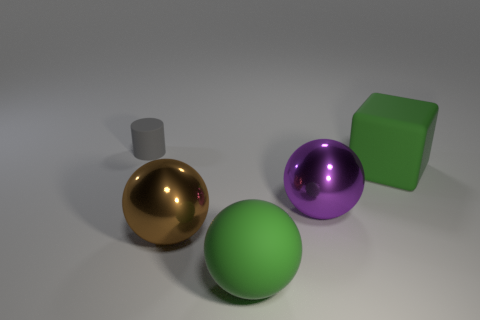How many other things are the same color as the big matte sphere?
Offer a very short reply. 1. What number of big green objects are in front of the large green matte thing on the right side of the green matte object that is in front of the purple metallic ball?
Give a very brief answer. 1. The other large metallic object that is the same shape as the large brown shiny object is what color?
Keep it short and to the point. Purple. There is a metal thing that is in front of the ball to the right of the green object in front of the large brown thing; what is its shape?
Make the answer very short. Sphere. There is a rubber object that is both left of the large purple metal ball and in front of the small rubber thing; how big is it?
Give a very brief answer. Large. Is the number of small metal spheres less than the number of large green rubber spheres?
Offer a terse response. Yes. There is a metallic sphere that is right of the large rubber sphere; how big is it?
Provide a succinct answer. Large. There is a thing that is both behind the big purple object and in front of the gray object; what shape is it?
Provide a short and direct response. Cube. There is a green matte thing that is the same shape as the brown metallic object; what is its size?
Your response must be concise. Large. What number of tiny gray things are the same material as the cube?
Offer a terse response. 1. 